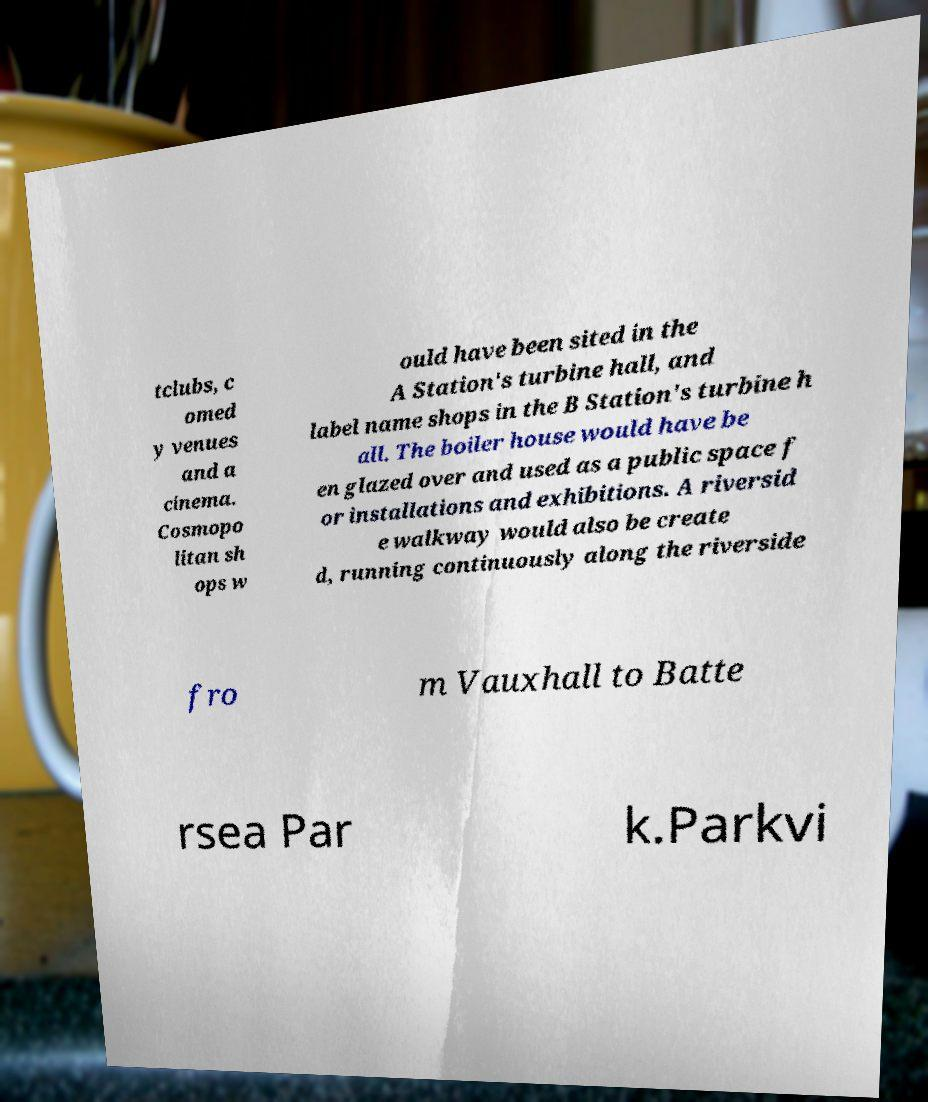There's text embedded in this image that I need extracted. Can you transcribe it verbatim? tclubs, c omed y venues and a cinema. Cosmopo litan sh ops w ould have been sited in the A Station's turbine hall, and label name shops in the B Station's turbine h all. The boiler house would have be en glazed over and used as a public space f or installations and exhibitions. A riversid e walkway would also be create d, running continuously along the riverside fro m Vauxhall to Batte rsea Par k.Parkvi 